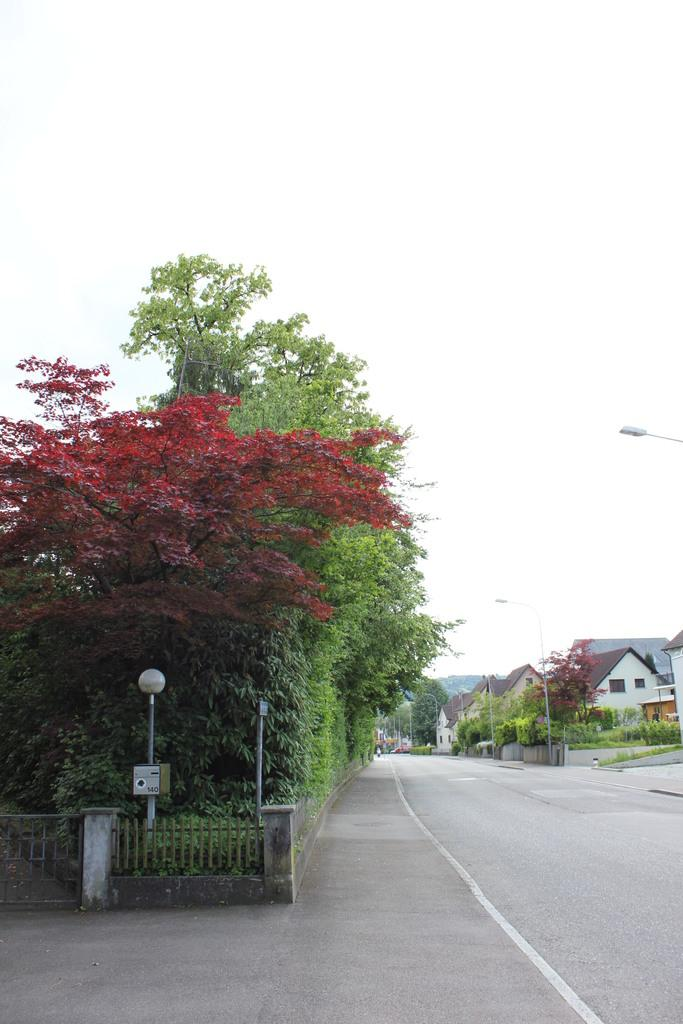What type of vegetation can be seen in the image? There are trees in the image. What structures are present in the image? There are poles and a fence in the image. What can be seen attached to the poles? There are lights attached to the poles in the image. What type of buildings can be seen in the background? There are houses in the background of the image. What is the story behind the need for the land in the image? There is no story or need for land mentioned in the image, as it only features trees, poles, lights, a fence, and houses in the background. 